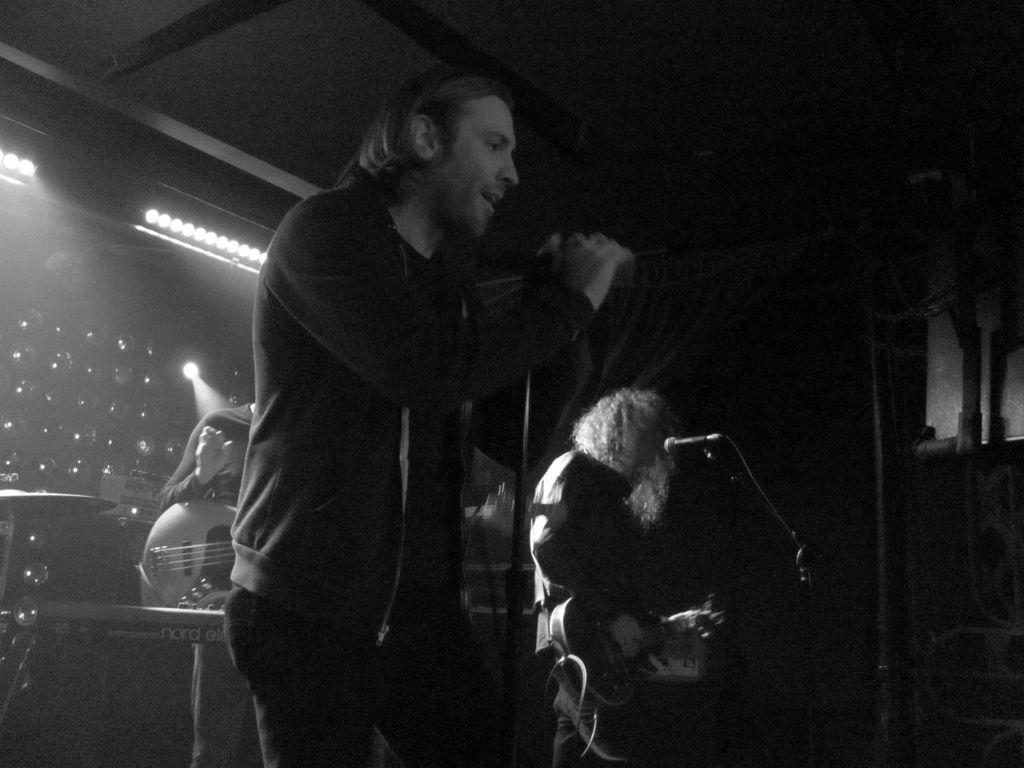What is the main subject of the image? The main subject of the image is a man. What is the man doing in the image? The man is standing and singing in the image. What object is the man holding in the image? The man is holding a microphone in the image. What can be seen behind the man in the image? There is a light visible behind the man in the image. Reasoning: Let' Let's think step by step in order to produce the conversation. We start by identifying the main subject of the image, which is the man. Then, we describe the man's actions and the object he is holding, which are singing and holding a microphone, respectively. Finally, we mention the light visible behind the man to provide additional context about the setting. Absurd Question/Answer: Can you see any ducks swimming in the seashore in the image? There is no seashore or ducks present in the image. How many cakes are on the table next to the man in the image? There is no table or cakes visible in the image. 